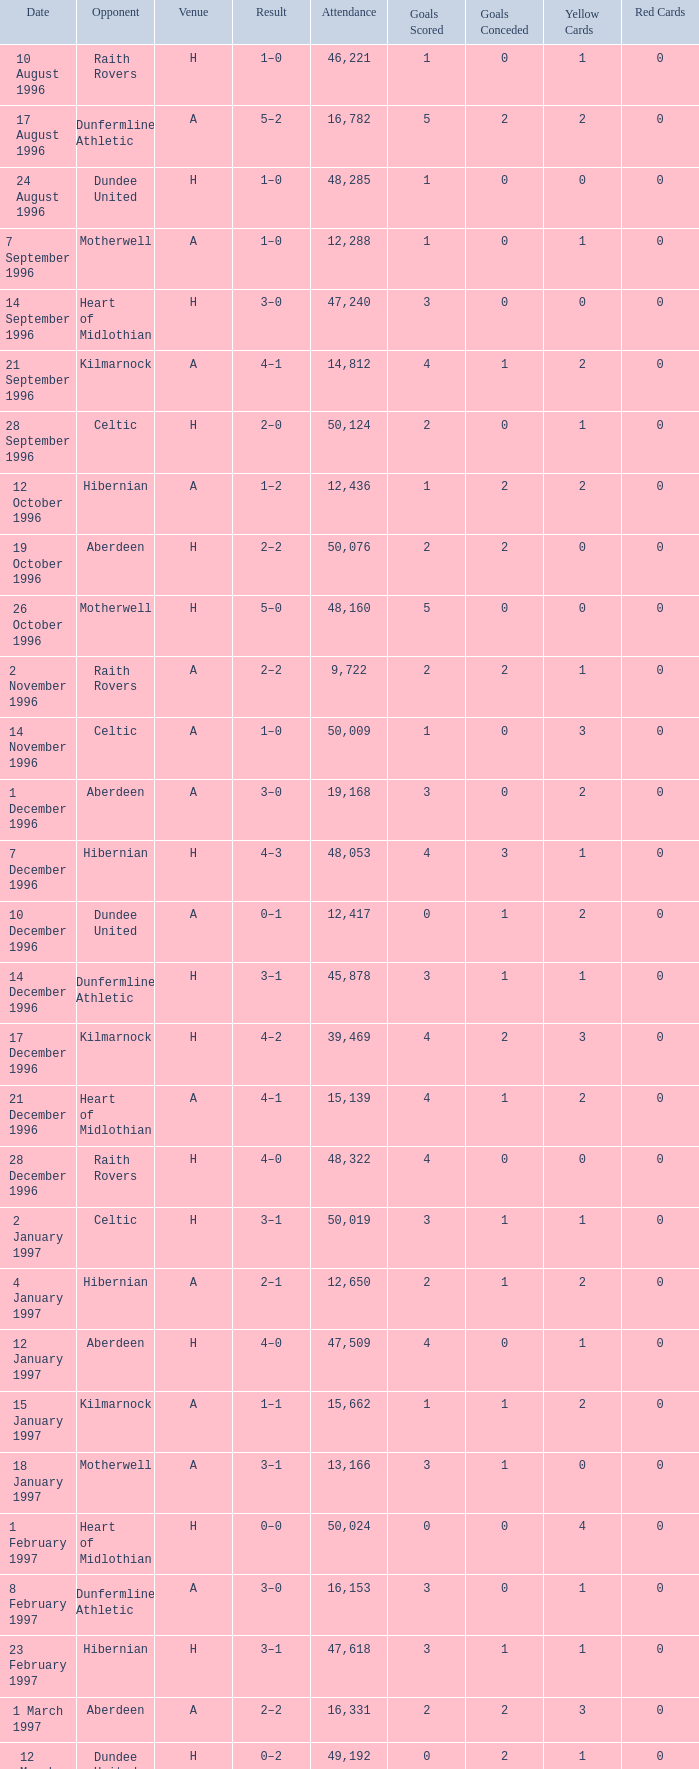When did venue A have an attendance larger than 48,053, and a result of 1–0? 14 November 1996, 16 March 1997. 